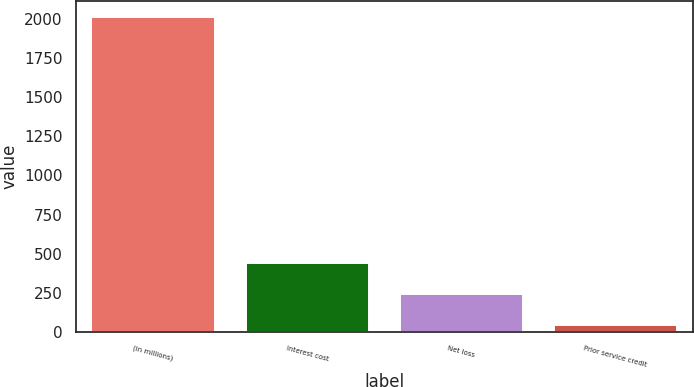Convert chart to OTSL. <chart><loc_0><loc_0><loc_500><loc_500><bar_chart><fcel>(in millions)<fcel>Interest cost<fcel>Net loss<fcel>Prior service credit<nl><fcel>2013<fcel>438.6<fcel>241.8<fcel>45<nl></chart> 